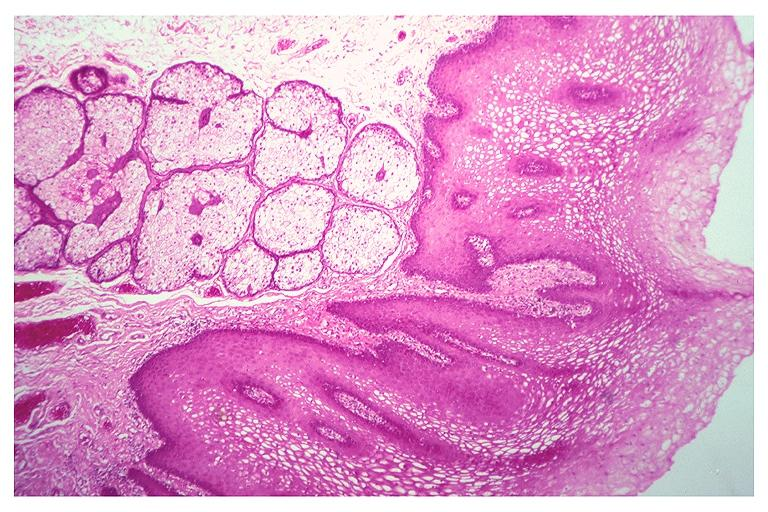what does this image show?
Answer the question using a single word or phrase. Fordyce granules 